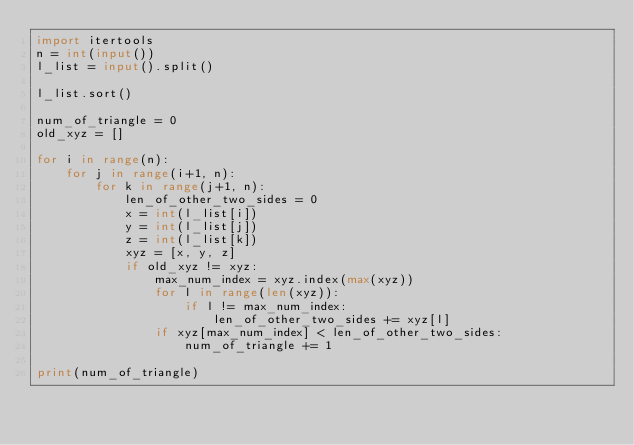Convert code to text. <code><loc_0><loc_0><loc_500><loc_500><_Python_>import itertools
n = int(input())
l_list = input().split()

l_list.sort()

num_of_triangle = 0
old_xyz = []

for i in range(n):
	for j in range(i+1, n):
		for k in range(j+1, n):
			len_of_other_two_sides = 0
			x = int(l_list[i])
			y = int(l_list[j])
			z = int(l_list[k])
			xyz = [x, y, z]
			if old_xyz != xyz:
				max_num_index = xyz.index(max(xyz))
				for l in range(len(xyz)):
					if l != max_num_index:
						len_of_other_two_sides += xyz[l]
				if xyz[max_num_index] < len_of_other_two_sides:
					num_of_triangle += 1

print(num_of_triangle)
</code> 